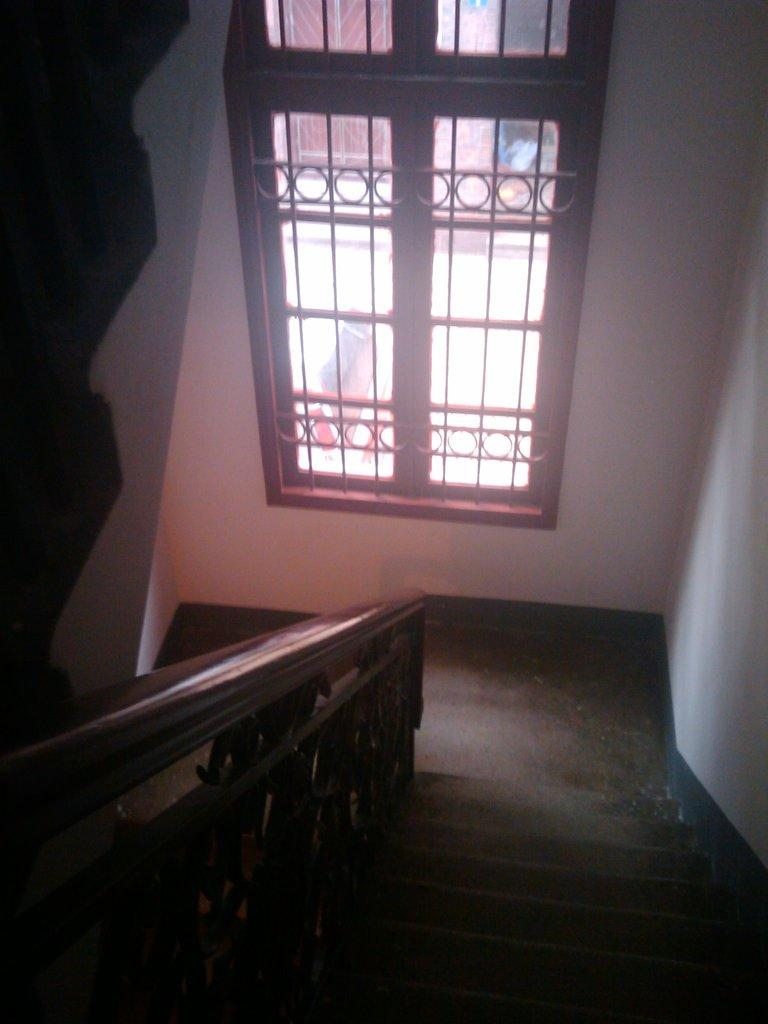What type of structure is present in the image? There is a staircase in the image. What feature is associated with the staircase for support or safety? There is a handrail associated with the staircase. What can be seen through the windows in the image? The presence of windows suggests that there is a view or natural light visible in the image. What type of architectural elements can be seen in the image? There are walls visible in the image. What type of trousers is the owl wearing while speaking in the image? There is no owl or voice present in the image, and therefore no trousers or speaking can be observed. 